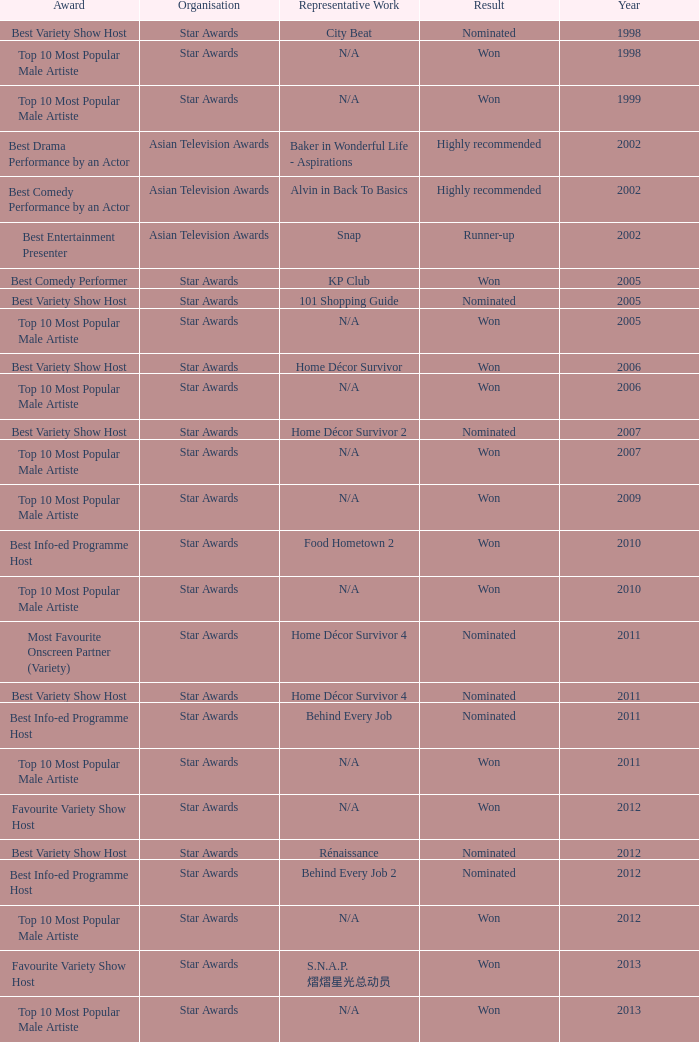What is the award for 1998 with Representative Work of city beat? Best Variety Show Host. 